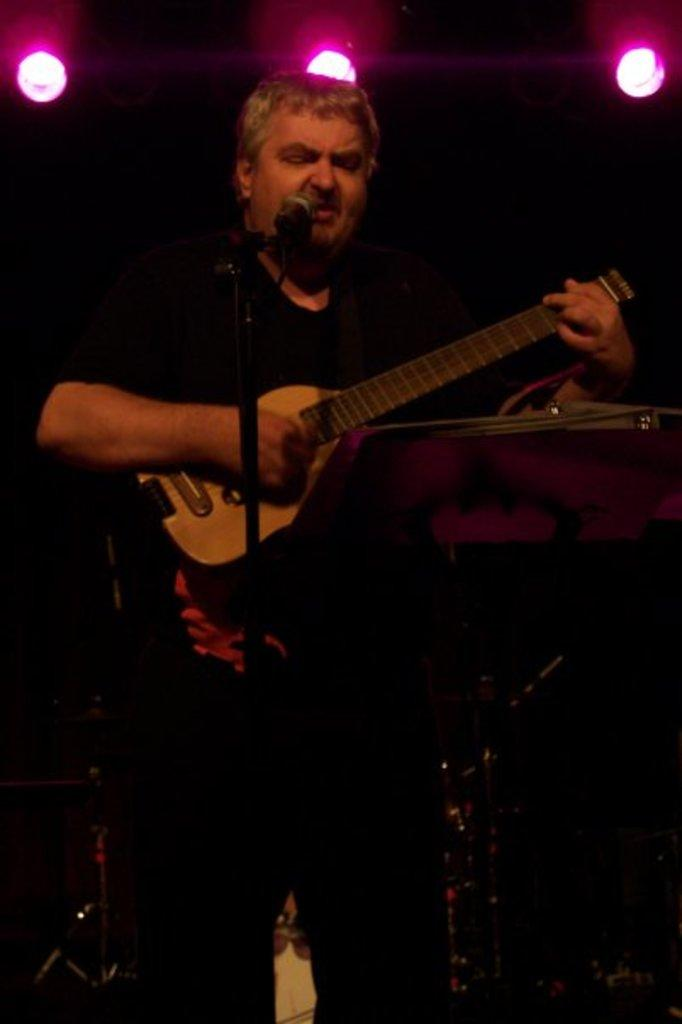What is the man in the image doing? The man is singing in the image. What tool is the man using while singing? The man is using a microphone. What musical instrument is the man playing? The man is playing a guitar. What is the man wearing while performing? The man is wearing a black costume. What type of cabbage can be seen growing in the background of the image? There is no cabbage present in the image; it features a man singing while using a microphone and playing a guitar. What is the flame used for in the image? There is no flame present in the image. 